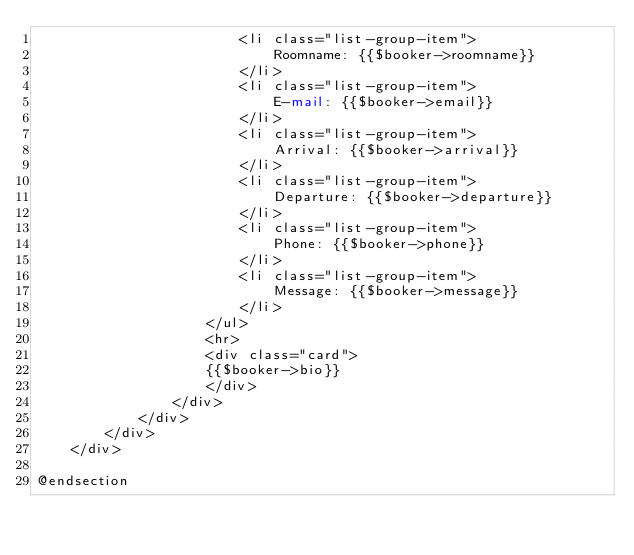Convert code to text. <code><loc_0><loc_0><loc_500><loc_500><_PHP_>                        <li class="list-group-item">
                            Roomname: {{$booker->roomname}}
                        </li>
                        <li class="list-group-item">
                            E-mail: {{$booker->email}}
                        </li>
                        <li class="list-group-item">
                            Arrival: {{$booker->arrival}}
                        </li>
                        <li class="list-group-item">
                            Departure: {{$booker->departure}}
                        </li>
                        <li class="list-group-item">
                            Phone: {{$booker->phone}}
                        </li>
                        <li class="list-group-item">
                            Message: {{$booker->message}}
                        </li>
                    </ul>
                    <hr>
                    <div class="card">
                    {{$booker->bio}}
                    </div>
                </div>
            </div>
        </div>
    </div>    

@endsection</code> 